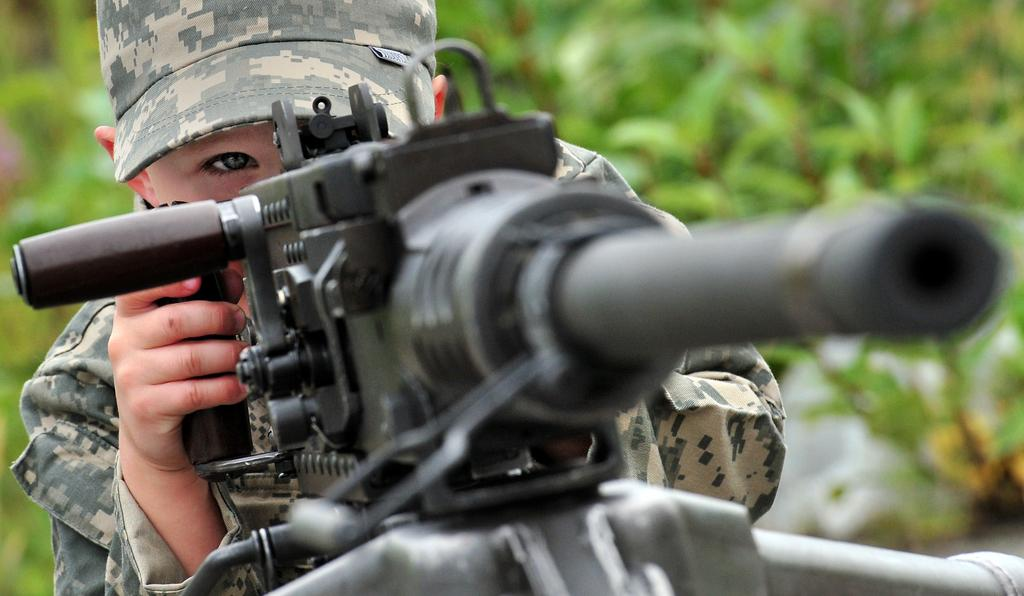What is the main subject of the image? The main subject of the image is a boy. What is the boy wearing on his head? The boy is wearing a cap on his head. What is the boy holding in his hands? The boy is holding a gun with his hands. What type of vegetation is visible in the image? There are plants visible in the image. What type of pet can be seen playing with a kite in the image? There is no pet or kite present in the image. What type of structure is visible in the background of the image? There is no structure visible in the background of the image. 